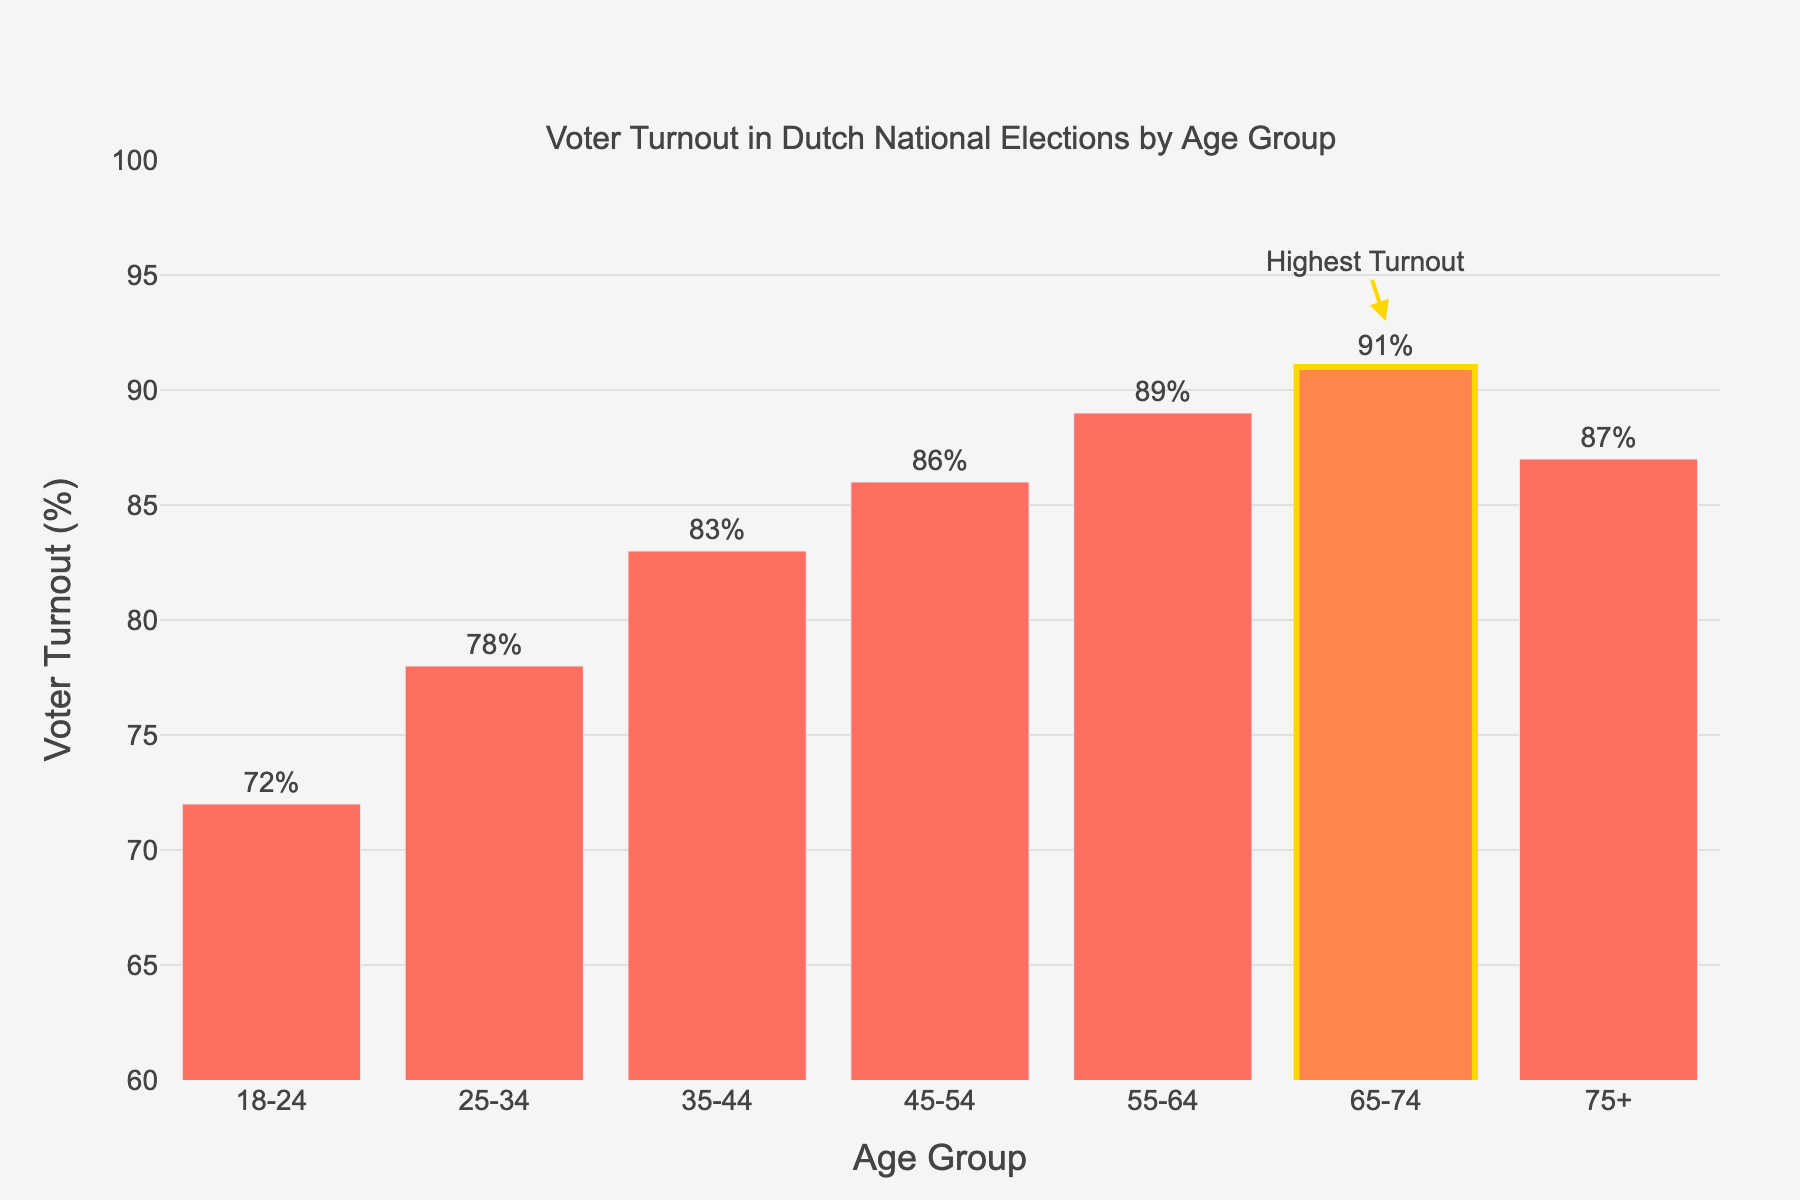What age group has the highest voter turnout? The highest voter turnout is indicated by the bar with the tallest height. The annotated "Highest Turnout" points to the 65-74 age group.
Answer: 65-74 Which age group has the lowest voter turnout? The shortest bar represents the lowest voter turnout. The 18-24 age group has the shortest bar in the plot.
Answer: 18-24 How much higher is the voter turnout for the 65-74 age group compared to the 18-24 age group? Subtract the voter turnout percentage of the 18-24 age group from that of the 65-74 age group: 91% - 72% = 19%.
Answer: 19% What is the average voter turnout rate among all age groups? Add together all the voter turnout rates and divide by the number of age groups: (72 + 78 + 83 + 86 + 89 + 91 + 87) / 7 = 83.71%.
Answer: 83.71% Which age group shows a voter turnout rate that is approximately in the middle of the range? The middle value of the sorted voter turnout rates can be found by identifying the median. The sorted rates are [72, 78, 83, 86, 87, 89, 91], making the median value fall in the 45-54 age group with 86%.
Answer: 45-54 What is the difference in voter turnout between the second highest and the second lowest age groups? Identify the second highest and second lowest voter turnout rates: second highest is 89% for 55-64, and second lowest is 78% for 25-34. The difference is 89% - 78% = 11%.
Answer: 11% Compare voter turnout rates between the age groups 35-44 and 75+. Which is higher and by how much? Subtract the voter turnout rate of the 35-44 age group from the 75+ age group: 87% - 83% = 4%. The 75+ age group has a higher turnout by 4%.
Answer: 75+ by 4% Which age group has a voter turnout rate closest to 80%? The voter turnout rates close to 80% are for the age groups 78% (25-34) and 83% (35-44). 78% is closer to 80%.
Answer: 25-34 What is the total combined voter turnout rate for the age groups 25-34 and 55-64? Add the voter turnout rates for 25-34 and 55-64: 78% + 89% = 167%.
Answer: 167% Which age group(s) have a voter turnout rate above the average turnout rate? First, calculate the average voter turnout rate, which is 83.71%. The age groups with rates above 83.71% are 45-54, 55-64, 65-74, and 75+ with respective turnouts of 86%, 89%, 91%, and 87%.
Answer: 45-54, 55-64, 65-74, 75+ 